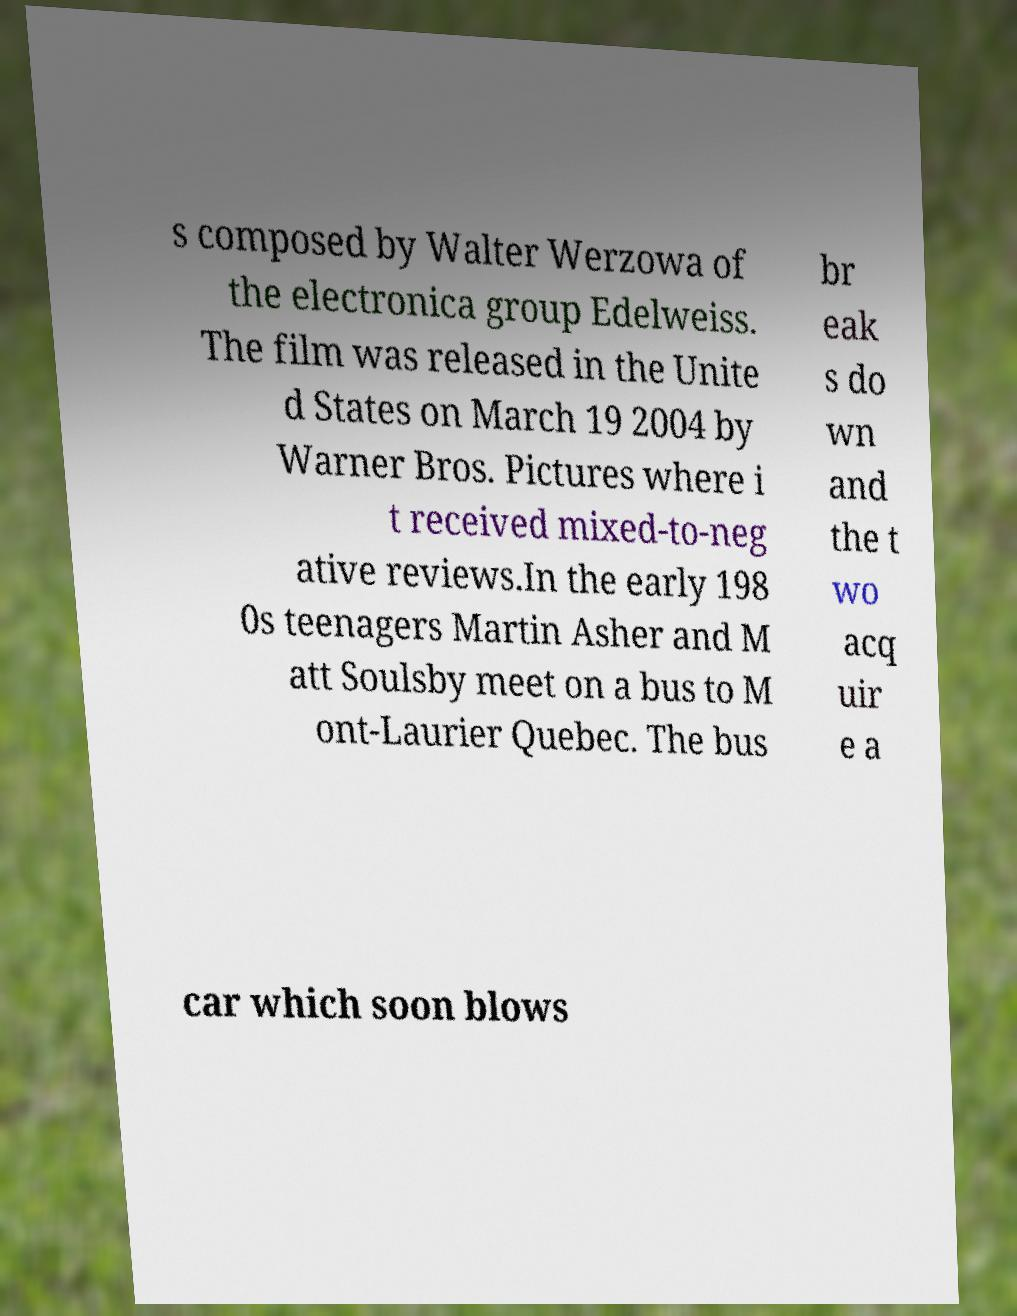Could you assist in decoding the text presented in this image and type it out clearly? s composed by Walter Werzowa of the electronica group Edelweiss. The film was released in the Unite d States on March 19 2004 by Warner Bros. Pictures where i t received mixed-to-neg ative reviews.In the early 198 0s teenagers Martin Asher and M att Soulsby meet on a bus to M ont-Laurier Quebec. The bus br eak s do wn and the t wo acq uir e a car which soon blows 